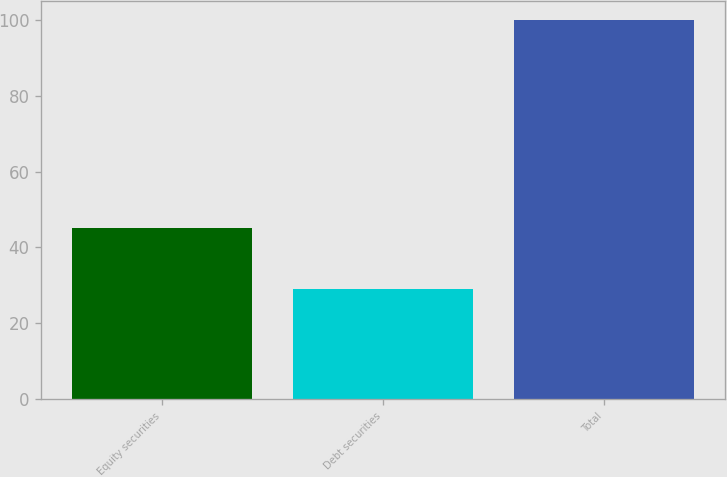Convert chart to OTSL. <chart><loc_0><loc_0><loc_500><loc_500><bar_chart><fcel>Equity securities<fcel>Debt securities<fcel>Total<nl><fcel>45<fcel>29<fcel>100<nl></chart> 